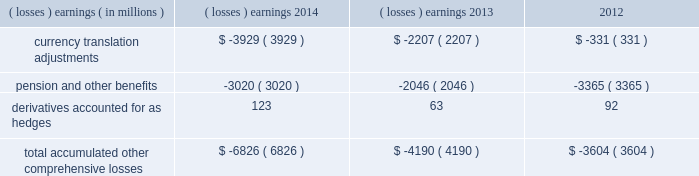Note 17 .
Accumulated other comprehensive losses : pmi's accumulated other comprehensive losses , net of taxes , consisted of the following: .
Reclassifications from other comprehensive earnings the movements in accumulated other comprehensive losses and the related tax impact , for each of the components above , that are due to current period activity and reclassifications to the income statement are shown on the consolidated statements of comprehensive earnings for the years ended december 31 , 2014 , 2013 , and 2012 .
The movement in currency translation adjustments for the year ended december 31 , 2013 , was also impacted by the purchase of the remaining shares of the mexican tobacco business .
In addition , $ 5 million and $ 12 million of net currency translation adjustment gains were transferred from other comprehensive earnings to marketing , administration and research costs in the consolidated statements of earnings for the years ended december 31 , 2014 and 2013 , respectively , upon liquidation of a subsidiary .
For additional information , see note 13 .
Benefit plans and note 15 .
Financial instruments for disclosures related to pmi's pension and other benefits and derivative financial instruments .
Note 18 .
Colombian investment and cooperation agreement : on june 19 , 2009 , pmi announced that it had signed an agreement with the republic of colombia , together with the departments of colombia and the capital district of bogota , to promote investment and cooperation with respect to the colombian tobacco market and to fight counterfeit and contraband tobacco products .
The investment and cooperation agreement provides $ 200 million in funding to the colombian governments over a 20-year period to address issues of mutual interest , such as combating the illegal cigarette trade , including the threat of counterfeit tobacco products , and increasing the quality and quantity of locally grown tobacco .
As a result of the investment and cooperation agreement , pmi recorded a pre-tax charge of $ 135 million in the operating results of the latin america & canada segment during the second quarter of 2009 .
At december 31 , 2014 and 2013 , pmi had $ 71 million and $ 74 million , respectively , of discounted liabilities associated with the colombian investment and cooperation agreement .
These discounted liabilities are primarily reflected in other long-term liabilities on the consolidated balance sheets and are expected to be paid through 2028 .
Note 19 .
Rbh legal settlement : on july 31 , 2008 , rothmans inc .
( "rothmans" ) announced the finalization of a cad 550 million settlement ( or approximately $ 540 million , based on the prevailing exchange rate at that time ) between itself and rothmans , benson & hedges inc .
( "rbh" ) , on the one hand , and the government of canada and all 10 provinces , on the other hand .
The settlement resolved the royal canadian mounted police's investigation relating to products exported from canada by rbh during the 1989-1996 period .
Rothmans' sole holding was a 60% ( 60 % ) interest in rbh .
The remaining 40% ( 40 % ) interest in rbh was owned by pmi. .
What was the change in total accumulated other comprehensive losses in millions from 2013 to 2014? 
Computations: (-6826 - -4190)
Answer: -2636.0. 